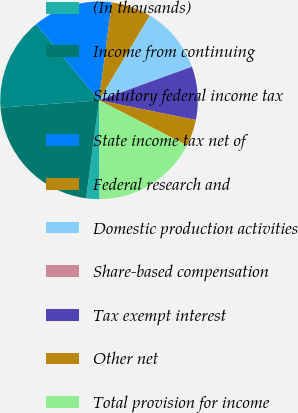<chart> <loc_0><loc_0><loc_500><loc_500><pie_chart><fcel>(In thousands)<fcel>Income from continuing<fcel>Statutory federal income tax<fcel>State income tax net of<fcel>Federal research and<fcel>Domestic production activities<fcel>Share-based compensation<fcel>Tax exempt interest<fcel>Other net<fcel>Total provision for income<nl><fcel>2.18%<fcel>21.73%<fcel>15.21%<fcel>13.04%<fcel>6.53%<fcel>10.87%<fcel>0.01%<fcel>8.7%<fcel>4.35%<fcel>17.38%<nl></chart> 